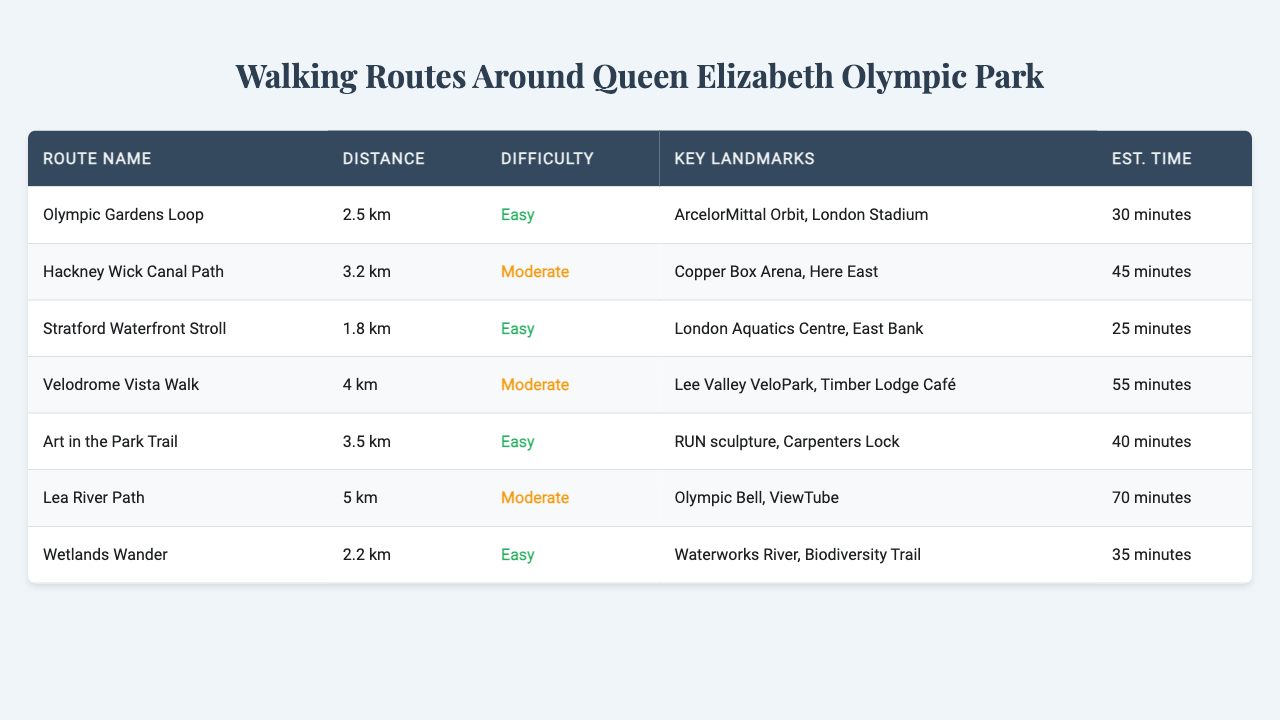What is the longest walking route listed in the table? The table lists all walking routes along with their distances. By examining the distances provided, the route with the longest distance is the "Lea River Path," which is 5 km long.
Answer: Lea River Path Which route has the shortest estimated time? The estimated times for all routes are noted in the table. The route with the shortest estimated time is the "Stratford Waterfront Stroll," taking 25 minutes.
Answer: Stratford Waterfront Stroll Are there any walking routes that are classified as easy? By looking at the difficulty column in the table, I can see that the routes classified as "Easy" are the "Olympic Gardens Loop," "Stratford Waterfront Stroll," "Art in the Park Trail," and "Wetlands Wander."
Answer: Yes How many routes have a distance of 3 km or more? The table lists each route along with its distance. I can count the routes that are 3 km or more, which includes "Hackney Wick Canal Path," "Art in the Park Trail," "Lea River Path," and "Velodrome Vista Walk" totaling four routes.
Answer: 4 What is the average distance of all the walking routes? First, summarize the distances as numerical values: 2.5, 3.2, 1.8, 4, 3.5, 5, and 2.2 km. Adding these distances gives 22.2 km. There are 7 routes, so the average is 22.2 km / 7 ≈ 3.17 km.
Answer: 3.17 km Is the route "Wetlands Wander" more difficult than "Olympic Gardens Loop"? The table shows that "Wetlands Wander" is classified as "Easy," while "Olympic Gardens Loop" is also classified as "Easy." Since they carry the same difficulty rating, "Wetlands Wander" is not more difficult.
Answer: No What percentage of the routes are classified as moderate? There are 7 routes in total. The moderate routes are "Hackney Wick Canal Path," "Velodrome Vista Walk," and "Lea River Path" totaling 3 routes. To find the percentage, calculate (3 / 7) * 100 = approximately 42.86%.
Answer: 42.86% Which route has the highest difficulty rating? After checking the difficulty levels in the table, both "Hackney Wick Canal Path" and "Lea River Path" are classified as "Moderate," which is the highest difficulty rating provided.
Answer: Hackney Wick Canal Path and Lea River Path What is the combined estimated time for the routes "Art in the Park Trail" and "Olympic Gardens Loop"? The estimated times are 40 minutes for "Art in the Park Trail" and 30 minutes for "Olympic Gardens Loop." Adding these gives 40 + 30 = 70 minutes.
Answer: 70 minutes Are there any routes that take more than an hour to complete? Looking through the estimated times, "Lea River Path" takes 70 minutes and "Velodrome Vista Walk" takes 55 minutes. Therefore, only "Lea River Path" exceeds an hour.
Answer: Yes, Lea River Path 